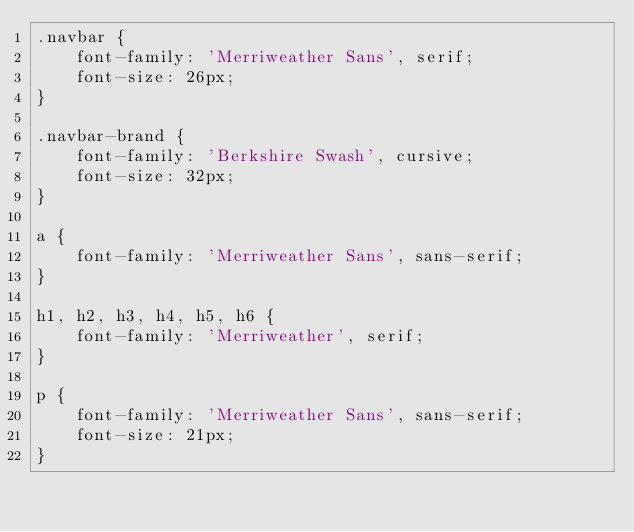Convert code to text. <code><loc_0><loc_0><loc_500><loc_500><_CSS_>.navbar {
	font-family: 'Merriweather Sans', serif;
	font-size: 26px;
}

.navbar-brand {
	font-family: 'Berkshire Swash', cursive;
	font-size: 32px;
}

a {
	font-family: 'Merriweather Sans', sans-serif;
}

h1, h2, h3, h4, h5, h6 {
	font-family: 'Merriweather', serif;
}

p {
	font-family: 'Merriweather Sans', sans-serif;
	font-size: 21px;
}</code> 